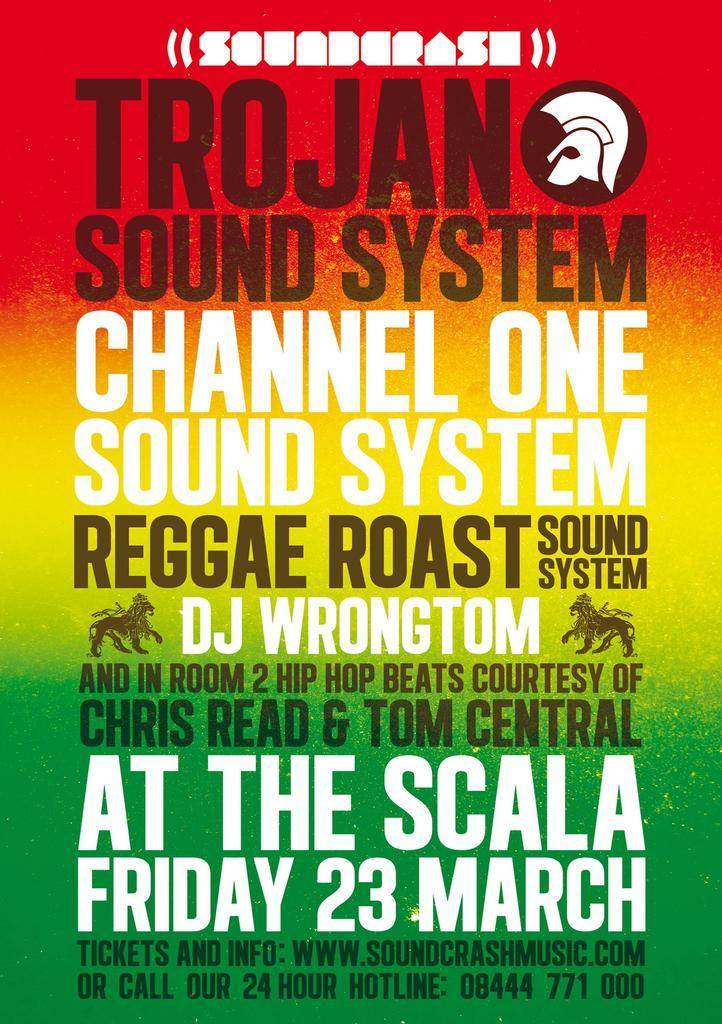<image>
Relay a brief, clear account of the picture shown. A poster advertising the Trojan Sound System Channel One Reggae Roast. 